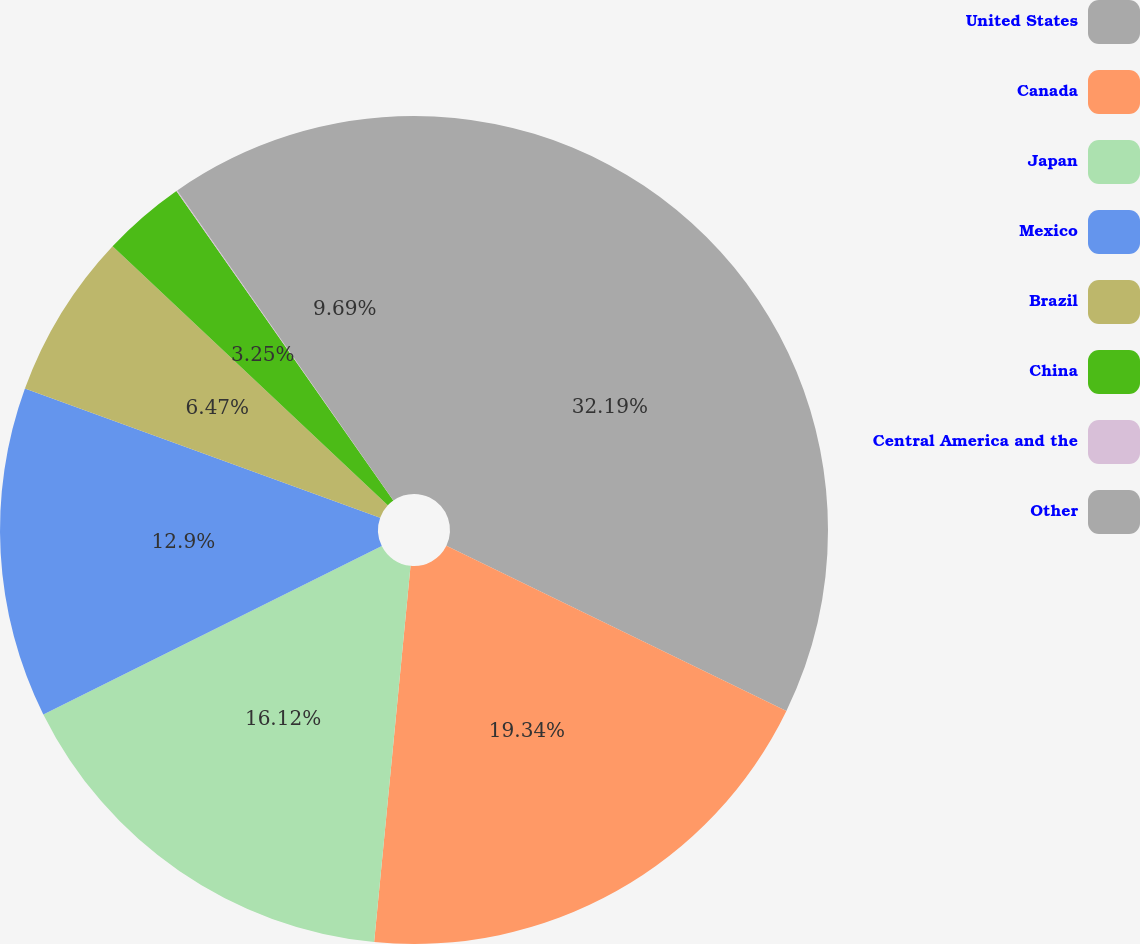<chart> <loc_0><loc_0><loc_500><loc_500><pie_chart><fcel>United States<fcel>Canada<fcel>Japan<fcel>Mexico<fcel>Brazil<fcel>China<fcel>Central America and the<fcel>Other<nl><fcel>32.2%<fcel>19.34%<fcel>16.12%<fcel>12.9%<fcel>6.47%<fcel>3.25%<fcel>0.04%<fcel>9.69%<nl></chart> 